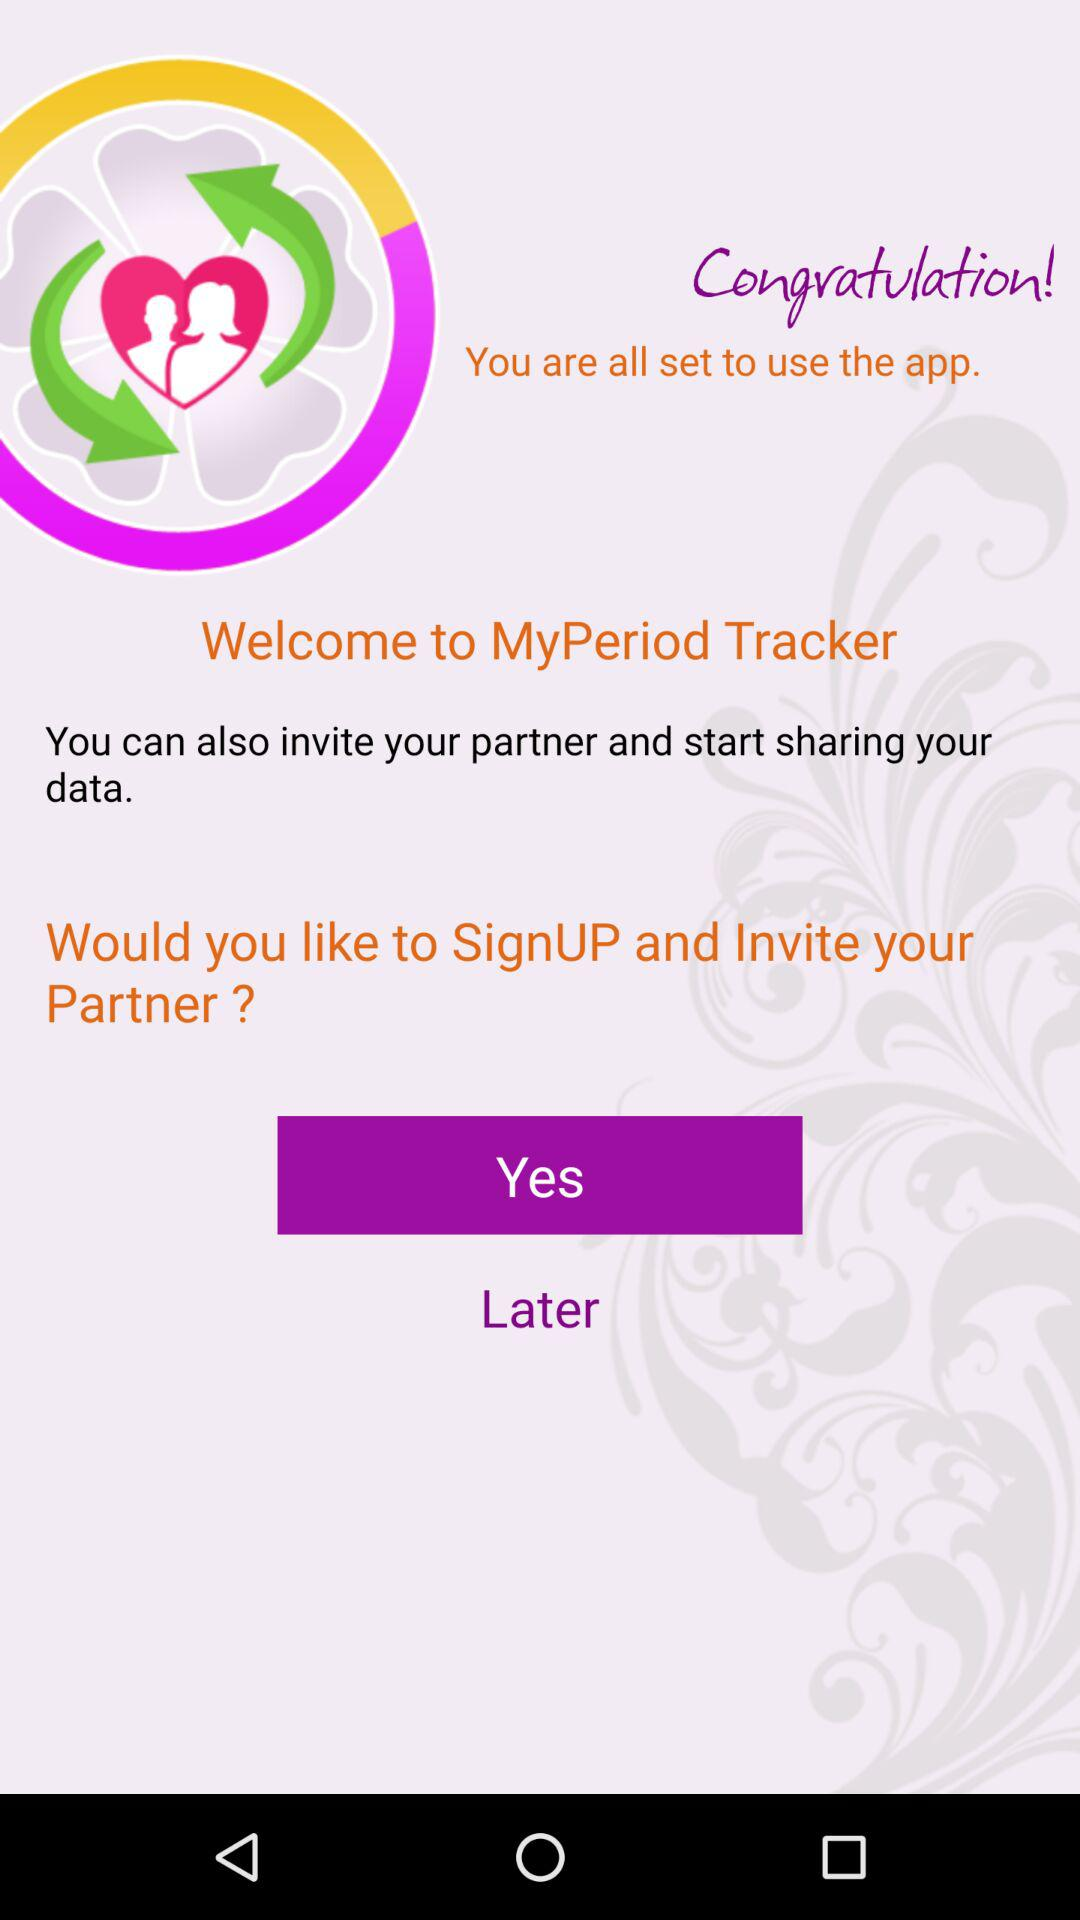What is the name of the application? The application name is "MyPeriod Tracker". 